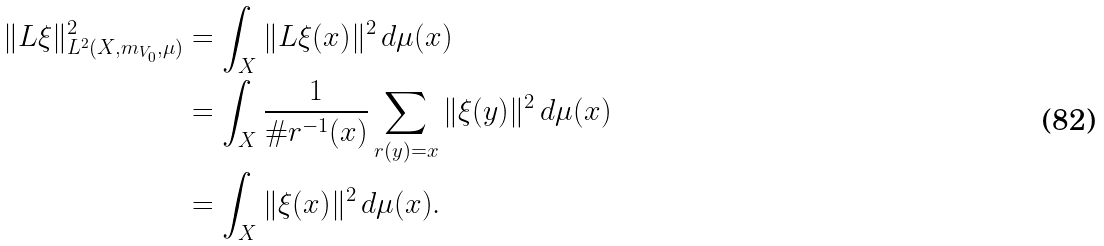Convert formula to latex. <formula><loc_0><loc_0><loc_500><loc_500>\| L \xi \| ^ { 2 } _ { L ^ { 2 } ( X , m _ { V _ { 0 } } , \mu ) } & = \int _ { X } \| L \xi ( x ) \| ^ { 2 } \, d \mu ( x ) \\ & = \int _ { X } \frac { 1 } { \# r ^ { - 1 } ( x ) } \sum _ { r ( y ) = x } \| \xi ( y ) \| ^ { 2 } \, d \mu ( x ) \\ & = \int _ { X } \| \xi ( x ) \| ^ { 2 } \, d \mu ( x ) .</formula> 